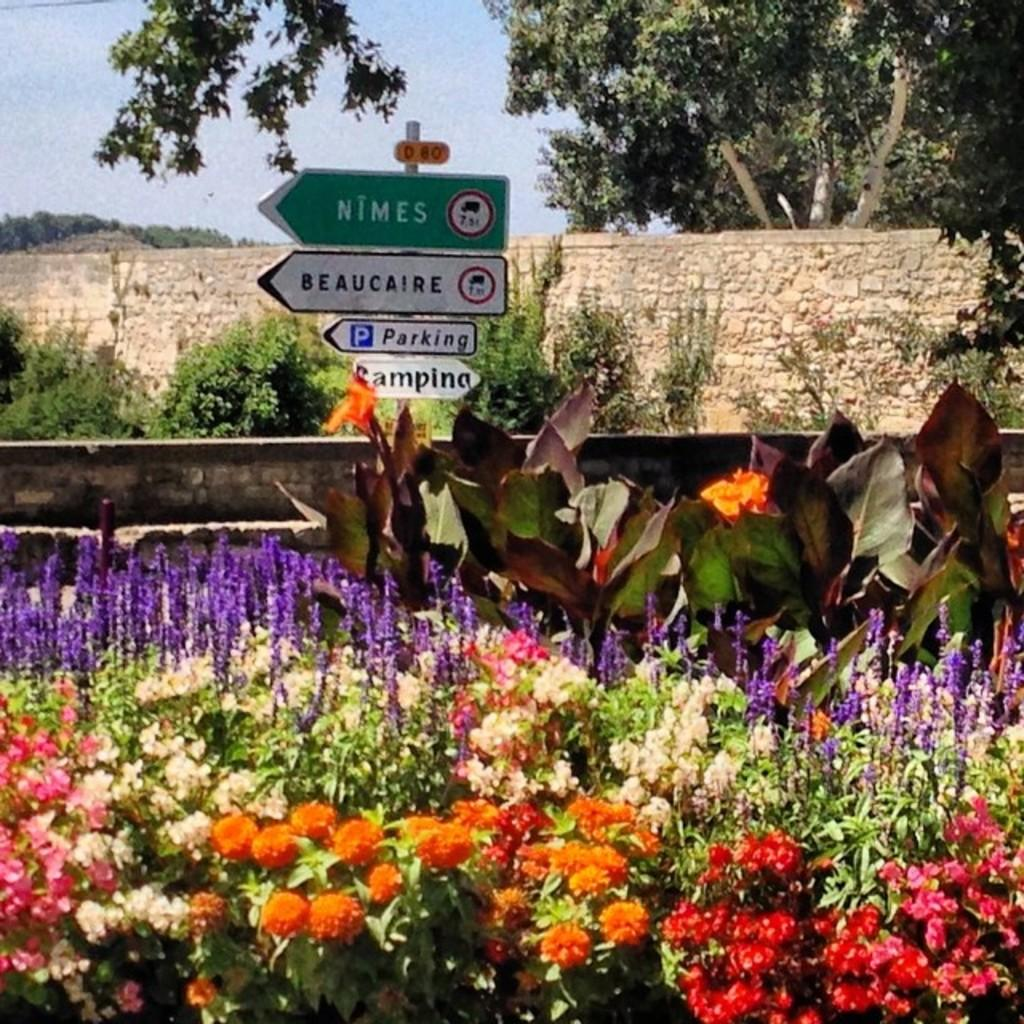What type of vegetation can be seen in the image? There are flowers, plants, and trees in the image. What type of structures are present in the image? There are walls and name boards attached to a pole in the image. What can be seen in the background of the image? The sky is visible in the background of the image. How many waves can be seen crashing on the shore in the image? There are no waves or shore visible in the image; it features flowers, plants, trees, walls, name boards, and the sky. 